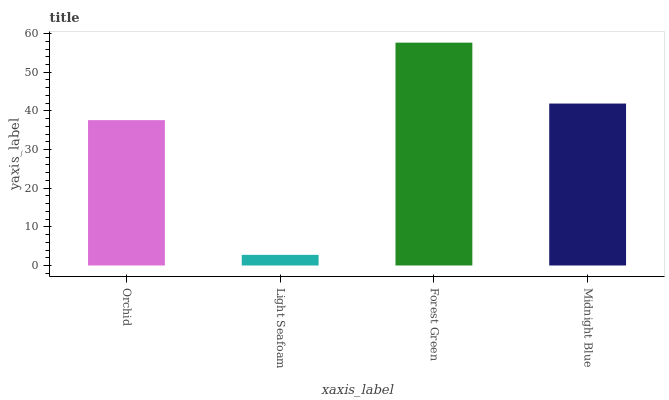Is Light Seafoam the minimum?
Answer yes or no. Yes. Is Forest Green the maximum?
Answer yes or no. Yes. Is Forest Green the minimum?
Answer yes or no. No. Is Light Seafoam the maximum?
Answer yes or no. No. Is Forest Green greater than Light Seafoam?
Answer yes or no. Yes. Is Light Seafoam less than Forest Green?
Answer yes or no. Yes. Is Light Seafoam greater than Forest Green?
Answer yes or no. No. Is Forest Green less than Light Seafoam?
Answer yes or no. No. Is Midnight Blue the high median?
Answer yes or no. Yes. Is Orchid the low median?
Answer yes or no. Yes. Is Orchid the high median?
Answer yes or no. No. Is Light Seafoam the low median?
Answer yes or no. No. 